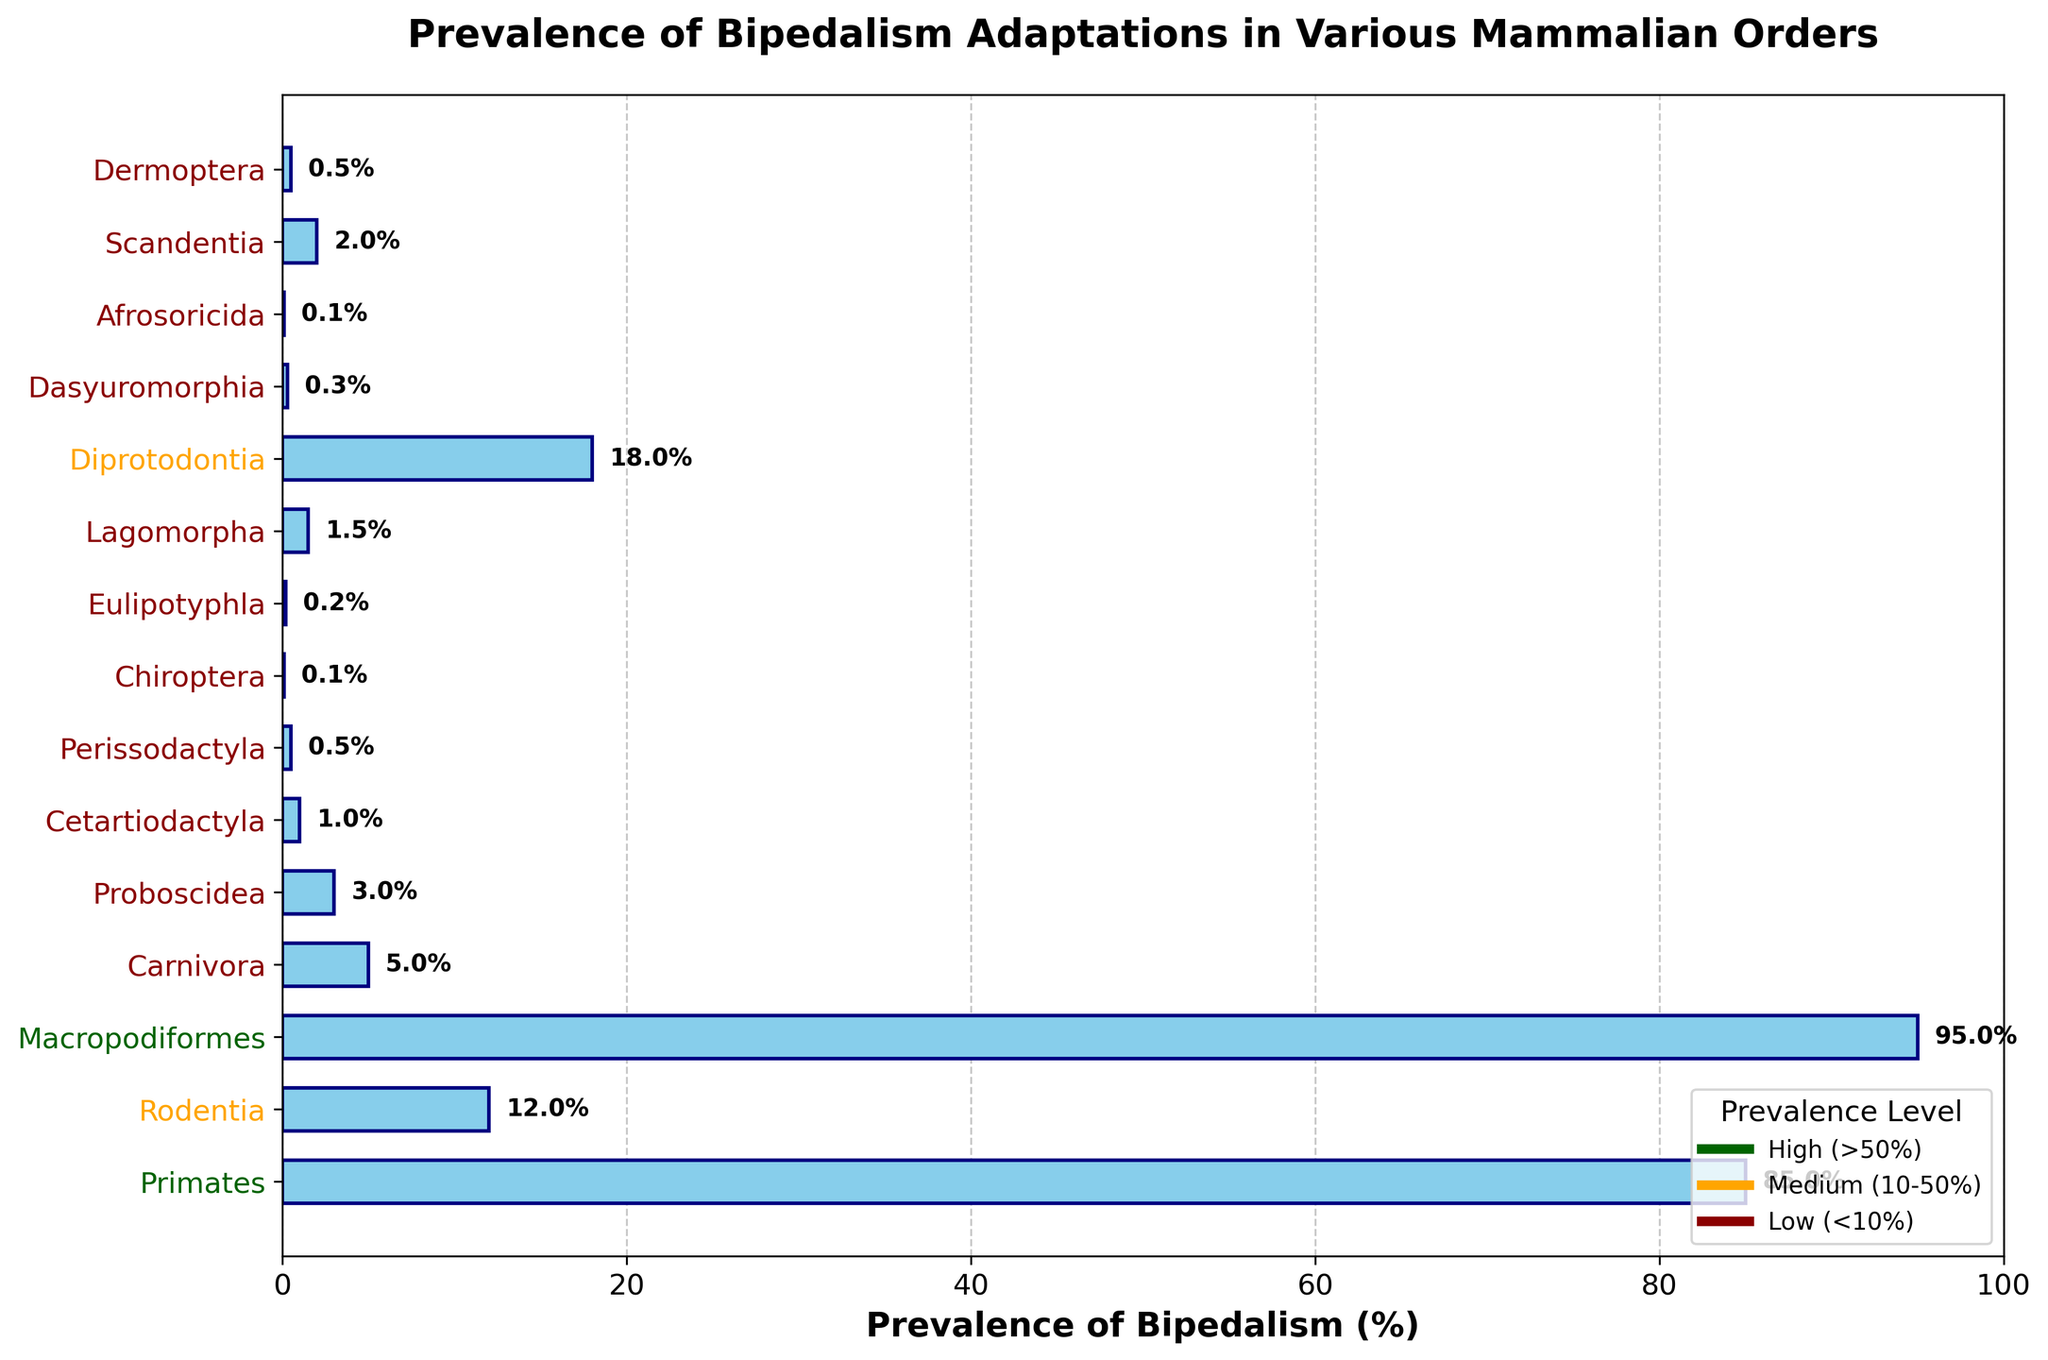Which mammalian order has the highest prevalence of bipedalism? The order with the highest bar represents the highest prevalence. Referring to the chart, Macropodiformes has the highest prevalence of bipedalism at 95%.
Answer: Macropodiformes Which three orders have the lowest prevalence of bipedalism and what are their percentages? Identify the smallest bars on the chart which represent the lowest prevalence. The three orders with the lowest prevalence are Chiroptera (0.1%), Afrosoricida (0.1%), and Eulipotyphla (0.2%).
Answer: Chiroptera (0.1%), Afrosoricida (0.1%), Eulipotyphla (0.2%) Is the prevalence of bipedalism in Primates higher than in Rodentia? If so, by how much? Compare the bars for Primates and Rodentia. Primates have a prevalence of 85%, and Rodentia has a prevalence of 12%. The difference is 85% - 12% = 73%.
Answer: Yes, by 73% What is the combined prevalence of bipedalism for Carnivora and Proboscidea? Add the prevalence values for Carnivora and Proboscidea. Carnivora has 5% and Proboscidea has 3%. The combined prevalence is 5% + 3% = 8%.
Answer: 8% Which orders have a prevalence of bipedalism greater than 50%? Identify the bars that extend past the 50% mark. The orders are Primates (85%) and Macropodiformes (95%).
Answer: Primates, Macropodiformes What is the prevalence of bipedalism in Lagomorpha and how does it compare to the prevalence in Scandentia? Identify the bars for Lagomorpha and Scandentia. Lagomorpha has a prevalence of 1.5% and Scandentia has 2%. Lagomorpha is less prevalent by 0.5%.
Answer: Lagomorpha is 0.5% less prevalent than Scandentia Among Perissodactyla, Diprotodontia, and Dasyuromorphia, which order has the medium prevalence and what is the value? Compare the bars for these three orders. Perissodactyla has 0.5%, Diprotodontia has 18%, and Dasyuromorphia has 0.3%. The medium value is 0.5% for Perissodactyla.
Answer: Perissodactyla (0.5%) What is the average prevalence of bipedalism for Carnivora, Proboscidea, and Cetartiodactyla? Sum the prevalence values and divide by the number of orders. (5% for Carnivora, 3% for Proboscidea, and 1% for Cetartiodactyla) The average is (5 + 3 + 1) / 3 = 3%.
Answer: 3% Which orders have their labels colored in dark green? Identify the y-axis labels that are colored in dark green, which indicate a prevalence above 50%. The orders are Primates and Macropodiformes.
Answer: Primates, Macropodiformes 